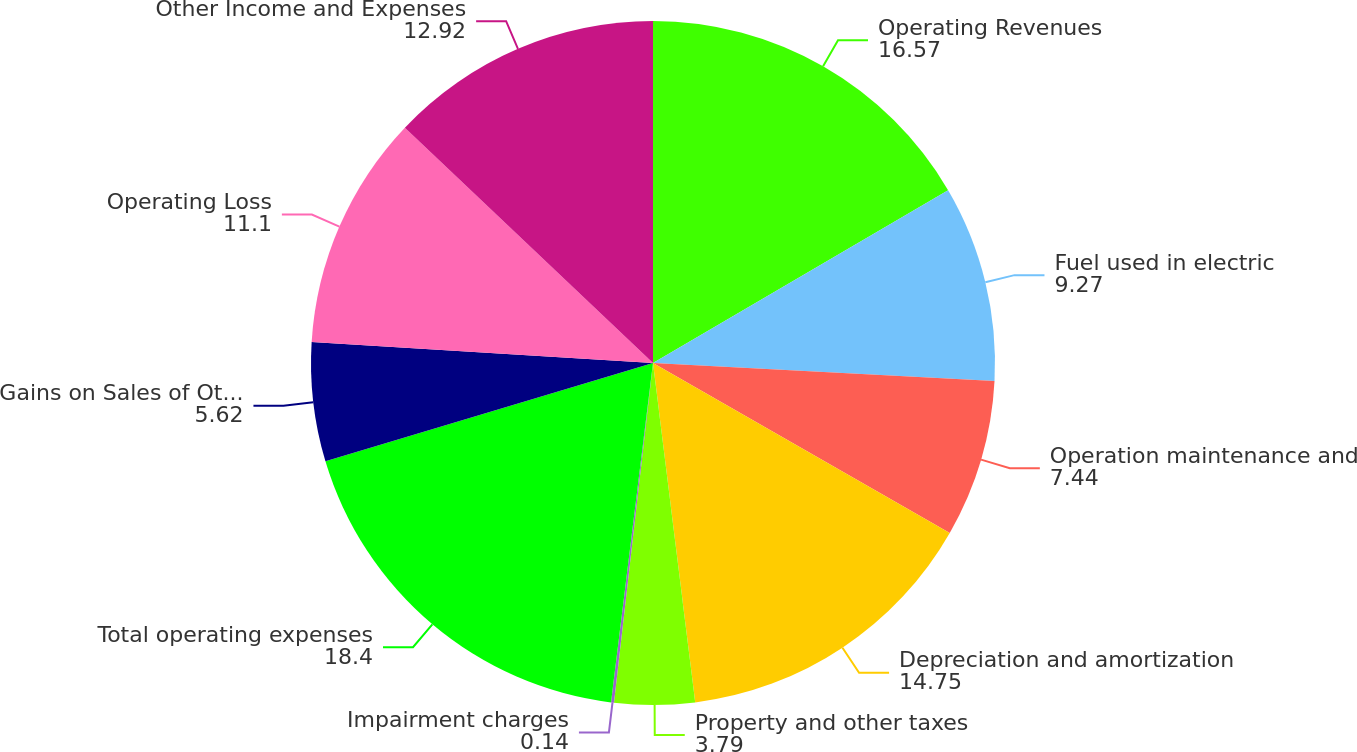<chart> <loc_0><loc_0><loc_500><loc_500><pie_chart><fcel>Operating Revenues<fcel>Fuel used in electric<fcel>Operation maintenance and<fcel>Depreciation and amortization<fcel>Property and other taxes<fcel>Impairment charges<fcel>Total operating expenses<fcel>Gains on Sales of Other Assets<fcel>Operating Loss<fcel>Other Income and Expenses<nl><fcel>16.57%<fcel>9.27%<fcel>7.44%<fcel>14.75%<fcel>3.79%<fcel>0.14%<fcel>18.4%<fcel>5.62%<fcel>11.1%<fcel>12.92%<nl></chart> 